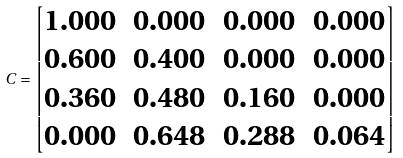Convert formula to latex. <formula><loc_0><loc_0><loc_500><loc_500>C = \begin{bmatrix} 1 . 0 0 0 & 0 . 0 0 0 & 0 . 0 0 0 & 0 . 0 0 0 \\ 0 . 6 0 0 & 0 . 4 0 0 & 0 . 0 0 0 & 0 . 0 0 0 \\ 0 . 3 6 0 & 0 . 4 8 0 & 0 . 1 6 0 & 0 . 0 0 0 \\ 0 . 0 0 0 & 0 . 6 4 8 & 0 . 2 8 8 & 0 . 0 6 4 \end{bmatrix}</formula> 